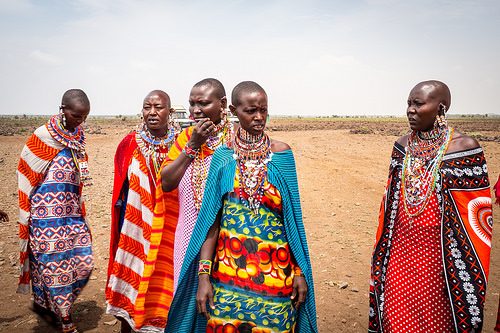<image>
Is there a blue lady in front of the pink lady? Yes. The blue lady is positioned in front of the pink lady, appearing closer to the camera viewpoint. 